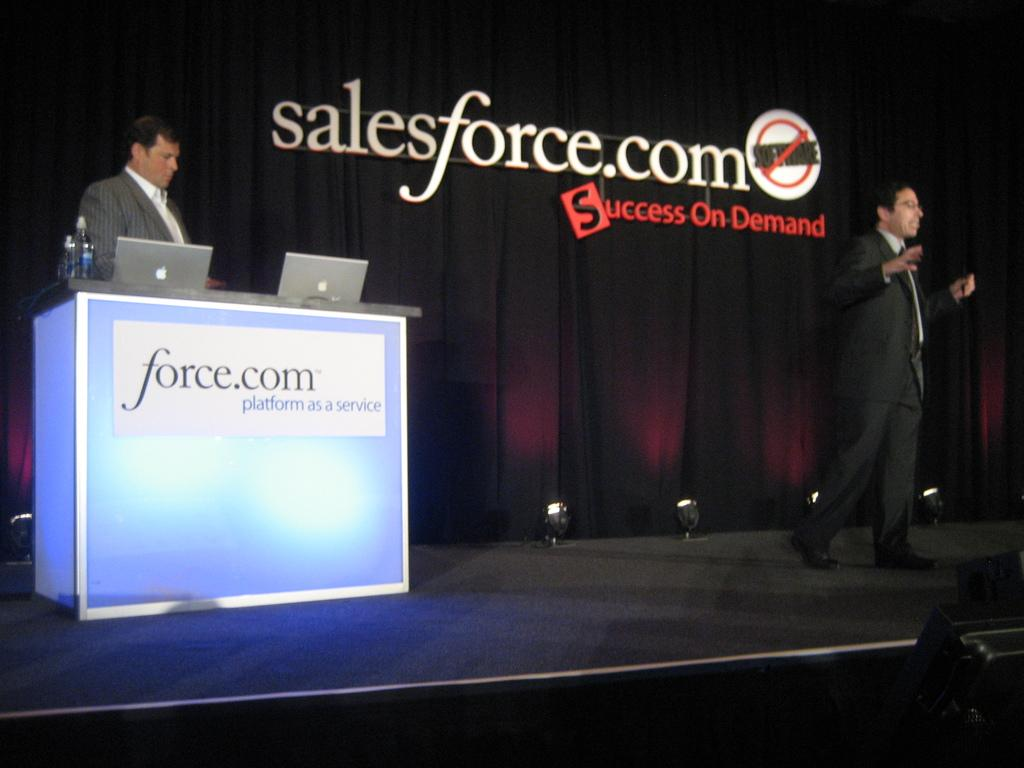What is happening on the stage in the image? There are people standing on the stage in the image. What electronic devices can be seen in the image? There are laptops visible in the image. What is on the podium in the image? There are bottles on the podium in the image. What type of fabric is present in the image? There are curtains in the image. What can be seen illuminating the stage in the image? There are lights in the image. What is the flat, rectangular object in the image? There is a board in the image. What type of jelly is being served on the board in the image? There is no jelly present in the image; it features a board with other items. How many crates are visible on the stage in the image? There are no crates visible on the stage in the image. 